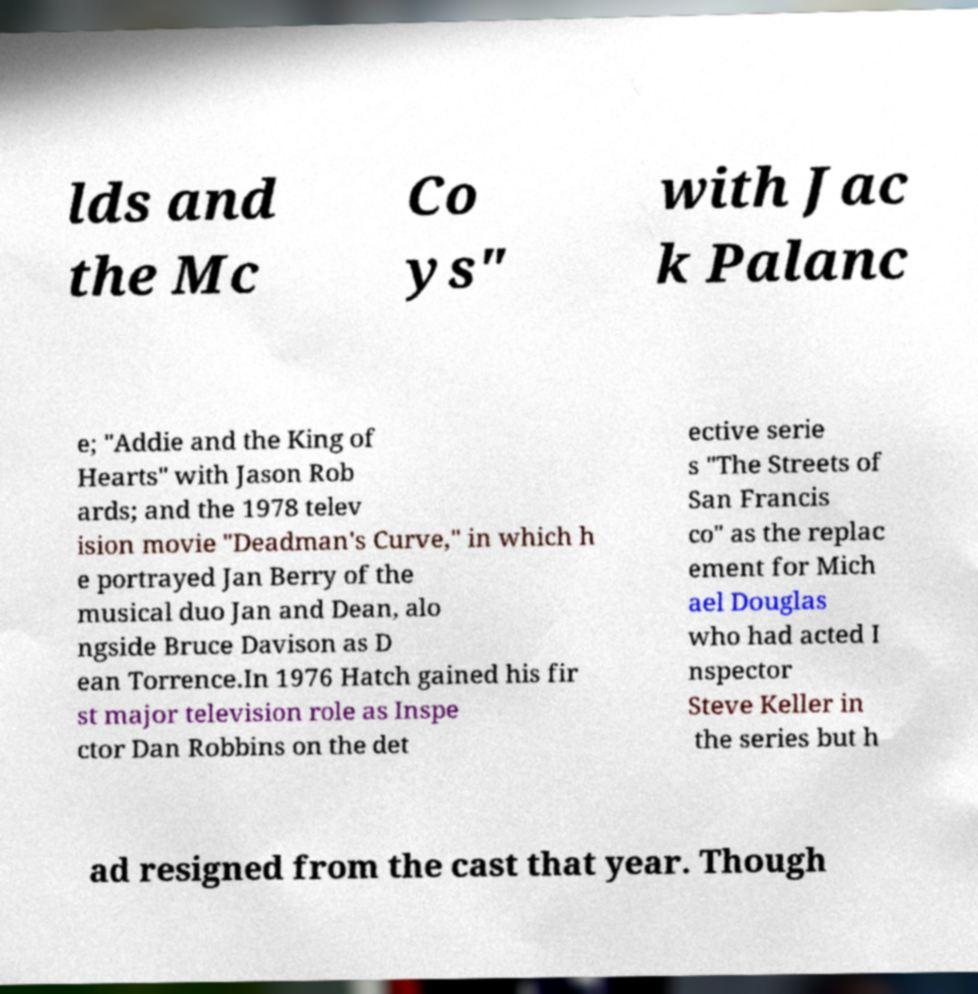Could you assist in decoding the text presented in this image and type it out clearly? lds and the Mc Co ys" with Jac k Palanc e; "Addie and the King of Hearts" with Jason Rob ards; and the 1978 telev ision movie "Deadman's Curve," in which h e portrayed Jan Berry of the musical duo Jan and Dean, alo ngside Bruce Davison as D ean Torrence.In 1976 Hatch gained his fir st major television role as Inspe ctor Dan Robbins on the det ective serie s "The Streets of San Francis co" as the replac ement for Mich ael Douglas who had acted I nspector Steve Keller in the series but h ad resigned from the cast that year. Though 